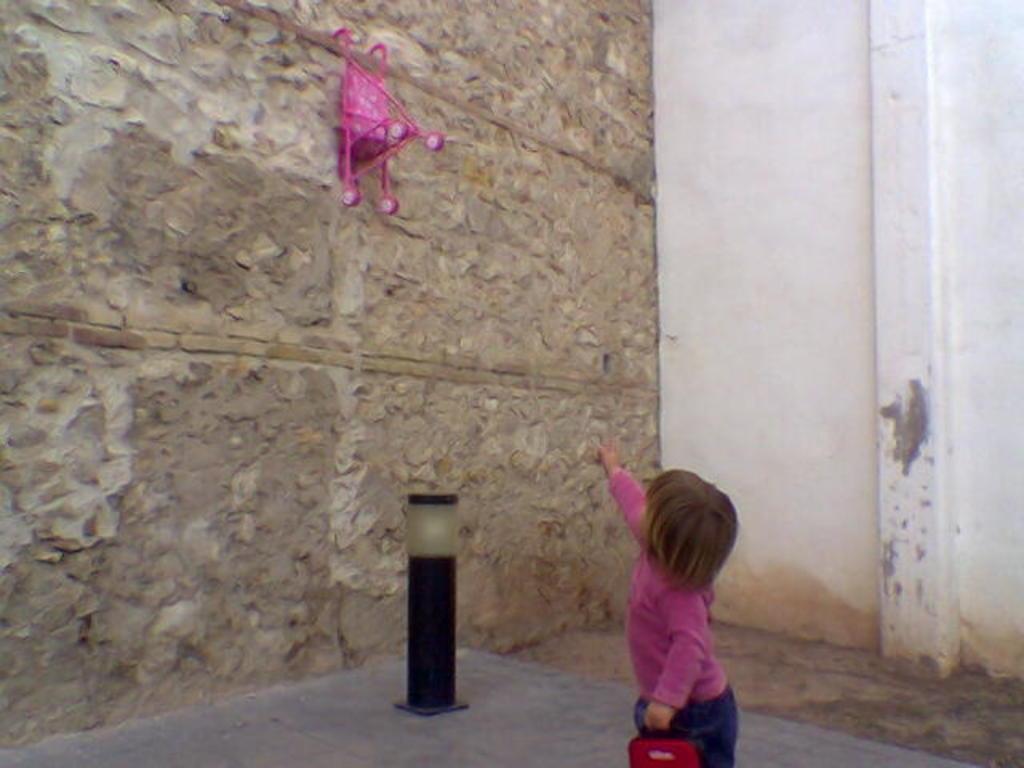How would you summarize this image in a sentence or two? In this image there is a child truncated towards the bottom of the image, the child is holding an object, there is an object on the ground, there is wall truncated towards the top of the image, there is wall truncated towards the left of the image, there is wall truncated towards the right of the image, there is an object on the wall. 